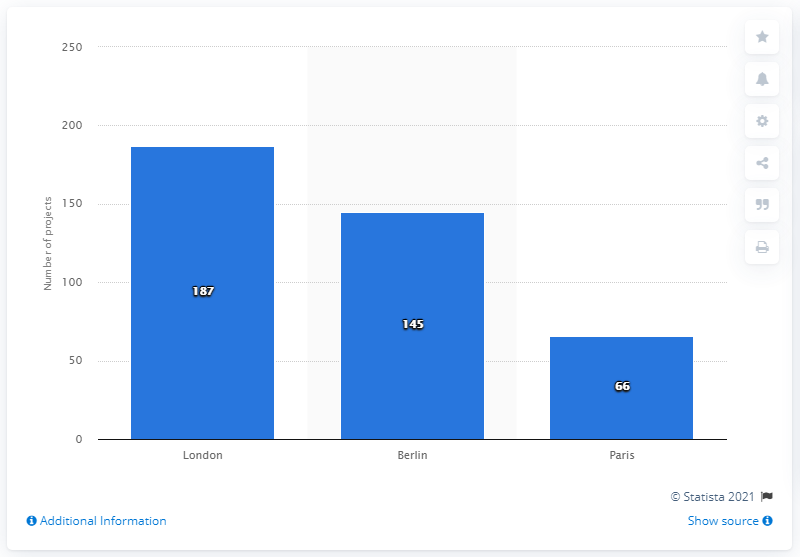Highlight a few significant elements in this photo. In the period from 2013 to September 2014, a total of 145 projects in Berlin received venture capital backing. In total, 187 projects in London received venture capital funding from 2013 to September 2014. 